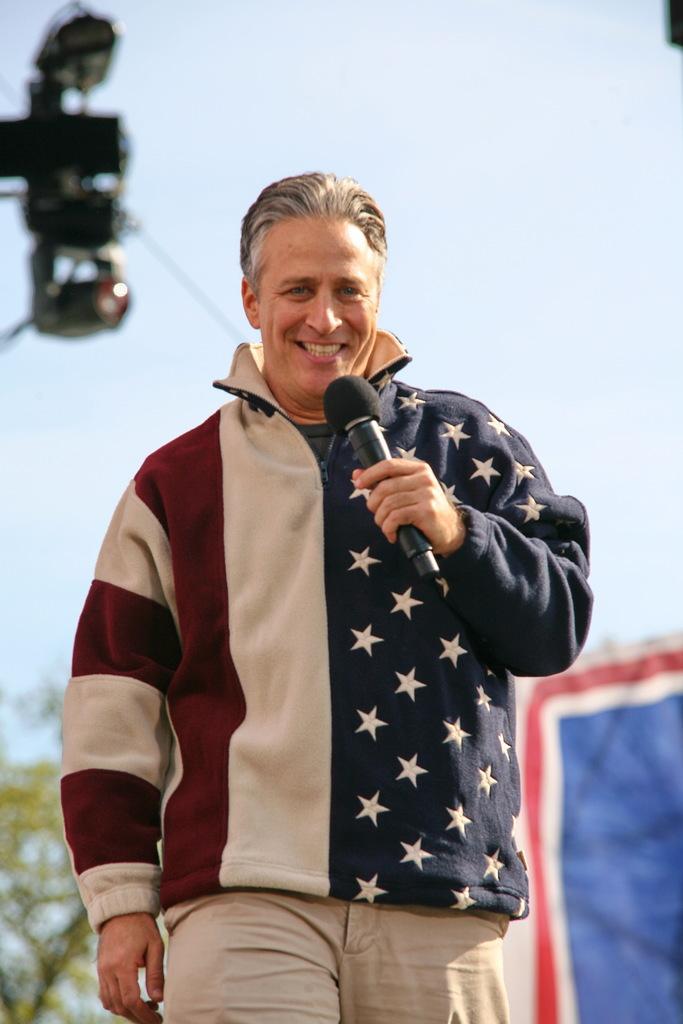How would you summarize this image in a sentence or two? In the picture we can see a man standing and holding a microphone and smiling and in the background, we can see a tree and a curtain and we can also see a sky. 